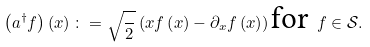<formula> <loc_0><loc_0><loc_500><loc_500>\left ( a _ { } ^ { \dag } f \right ) \left ( x \right ) \colon = \sqrt { \frac { } { 2 } } \left ( x f \left ( x \right ) - \partial _ { x } f \left ( x \right ) \right ) \text {for } f \in \mathcal { S } .</formula> 